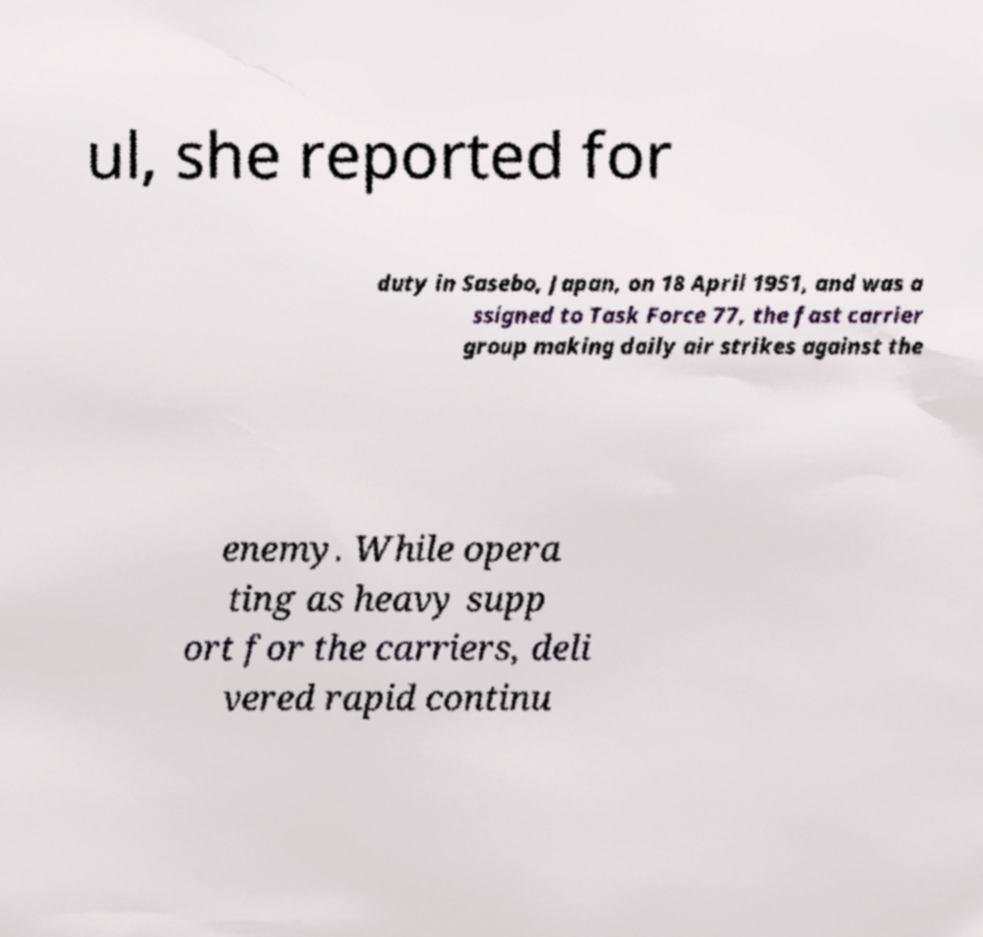Can you accurately transcribe the text from the provided image for me? ul, she reported for duty in Sasebo, Japan, on 18 April 1951, and was a ssigned to Task Force 77, the fast carrier group making daily air strikes against the enemy. While opera ting as heavy supp ort for the carriers, deli vered rapid continu 